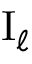<formula> <loc_0><loc_0><loc_500><loc_500>I _ { \ell }</formula> 